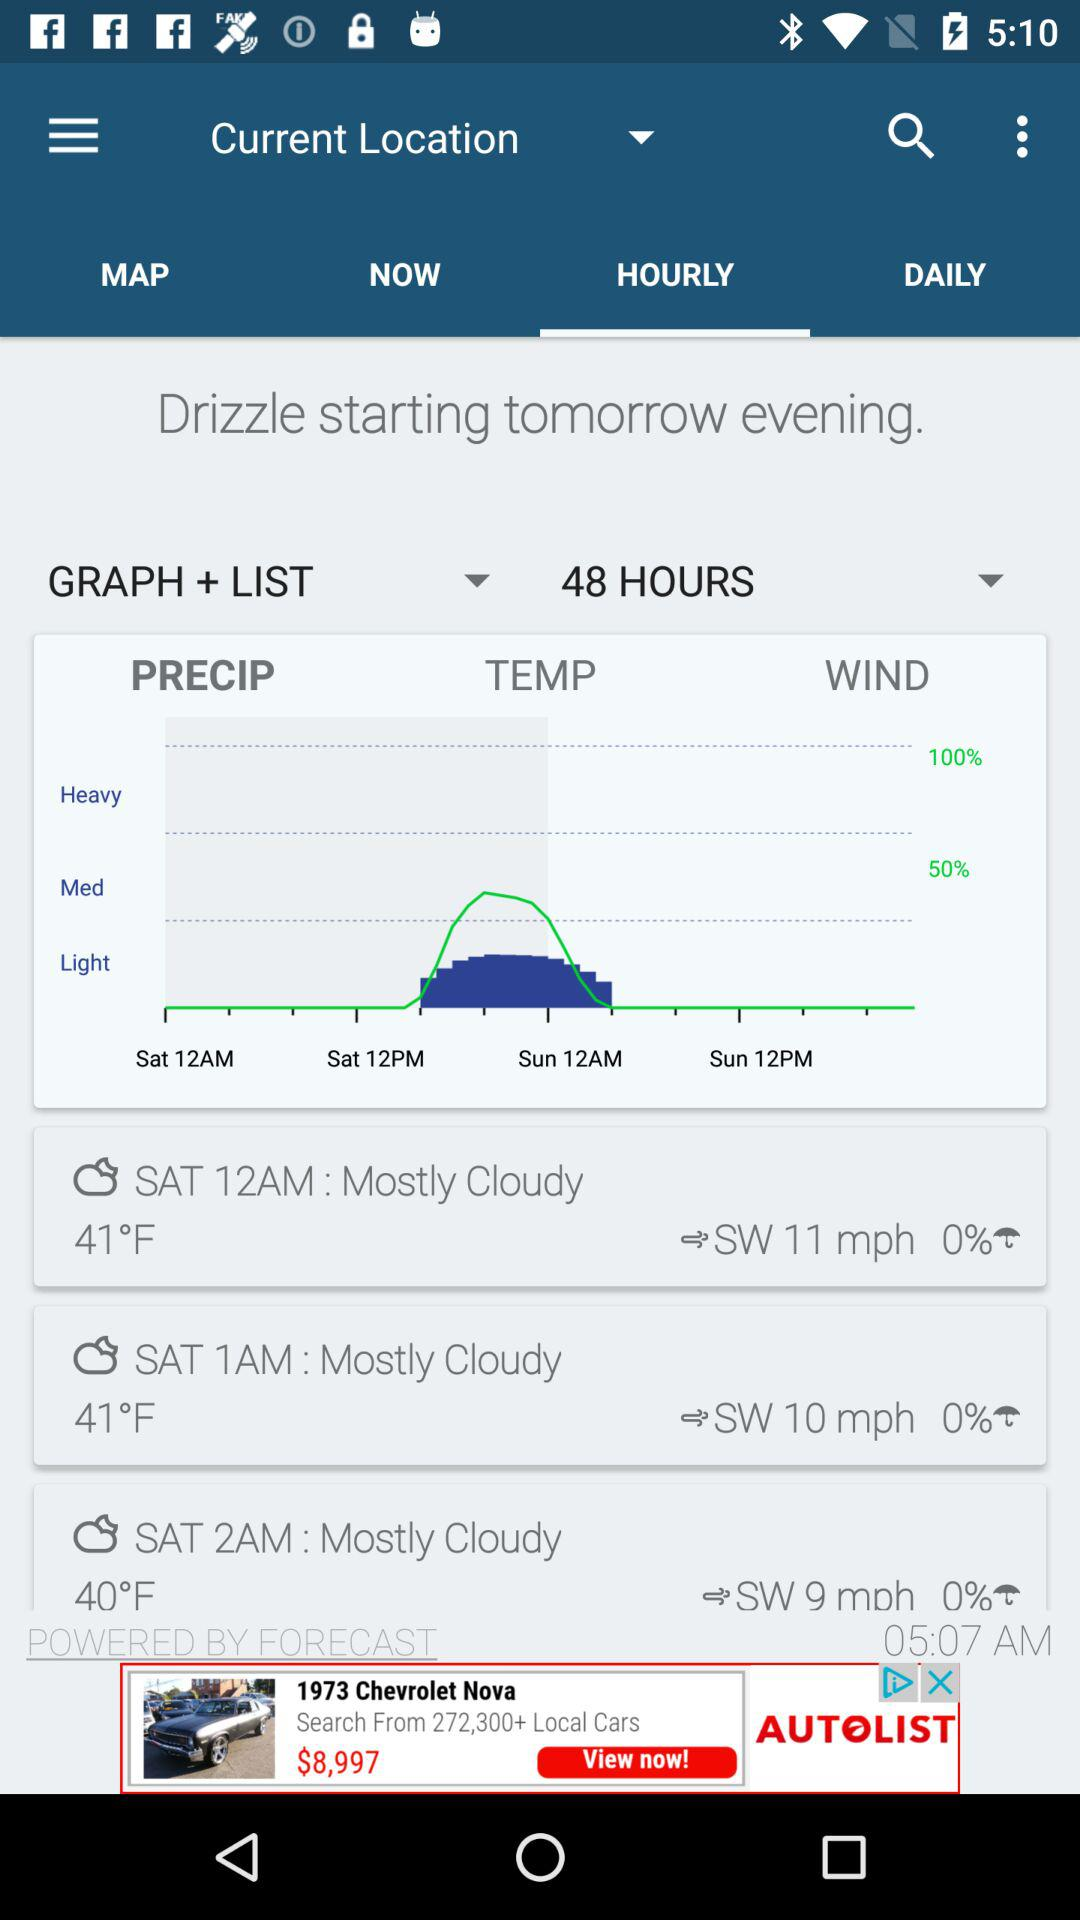Is there going to be any heavy rainfall according to the forecast in the image? Looking at the image, the forecast does not indicate any heavy rainfall for the next 48 hours. The precipitation graph shows light to medium levels of precipitation, peaking around noon but staying well below the 'heavy' category. 